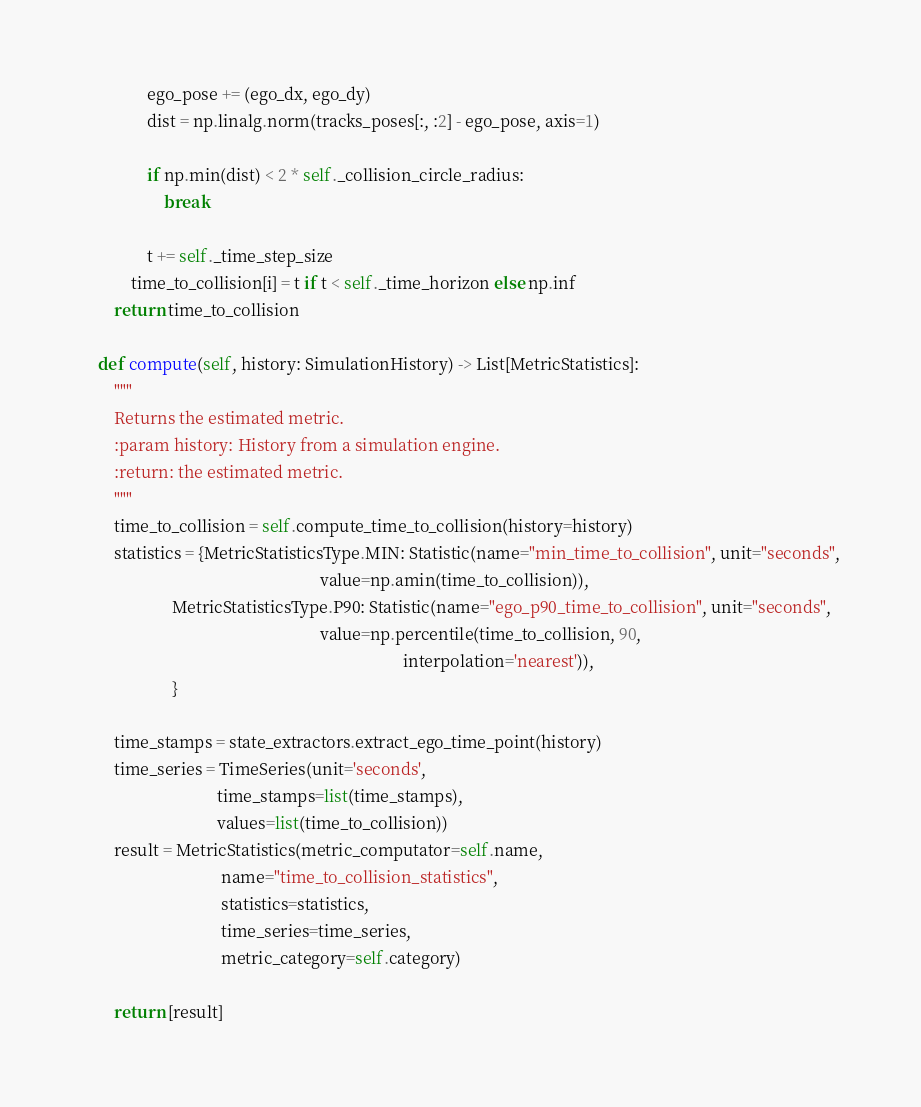<code> <loc_0><loc_0><loc_500><loc_500><_Python_>                ego_pose += (ego_dx, ego_dy)
                dist = np.linalg.norm(tracks_poses[:, :2] - ego_pose, axis=1)

                if np.min(dist) < 2 * self._collision_circle_radius:
                    break

                t += self._time_step_size
            time_to_collision[i] = t if t < self._time_horizon else np.inf
        return time_to_collision

    def compute(self, history: SimulationHistory) -> List[MetricStatistics]:
        """
        Returns the estimated metric.
        :param history: History from a simulation engine.
        :return: the estimated metric.
        """
        time_to_collision = self.compute_time_to_collision(history=history)
        statistics = {MetricStatisticsType.MIN: Statistic(name="min_time_to_collision", unit="seconds",
                                                          value=np.amin(time_to_collision)),
                      MetricStatisticsType.P90: Statistic(name="ego_p90_time_to_collision", unit="seconds",
                                                          value=np.percentile(time_to_collision, 90,
                                                                              interpolation='nearest')),
                      }

        time_stamps = state_extractors.extract_ego_time_point(history)
        time_series = TimeSeries(unit='seconds',
                                 time_stamps=list(time_stamps),
                                 values=list(time_to_collision))
        result = MetricStatistics(metric_computator=self.name,
                                  name="time_to_collision_statistics",
                                  statistics=statistics,
                                  time_series=time_series,
                                  metric_category=self.category)

        return [result]
</code> 